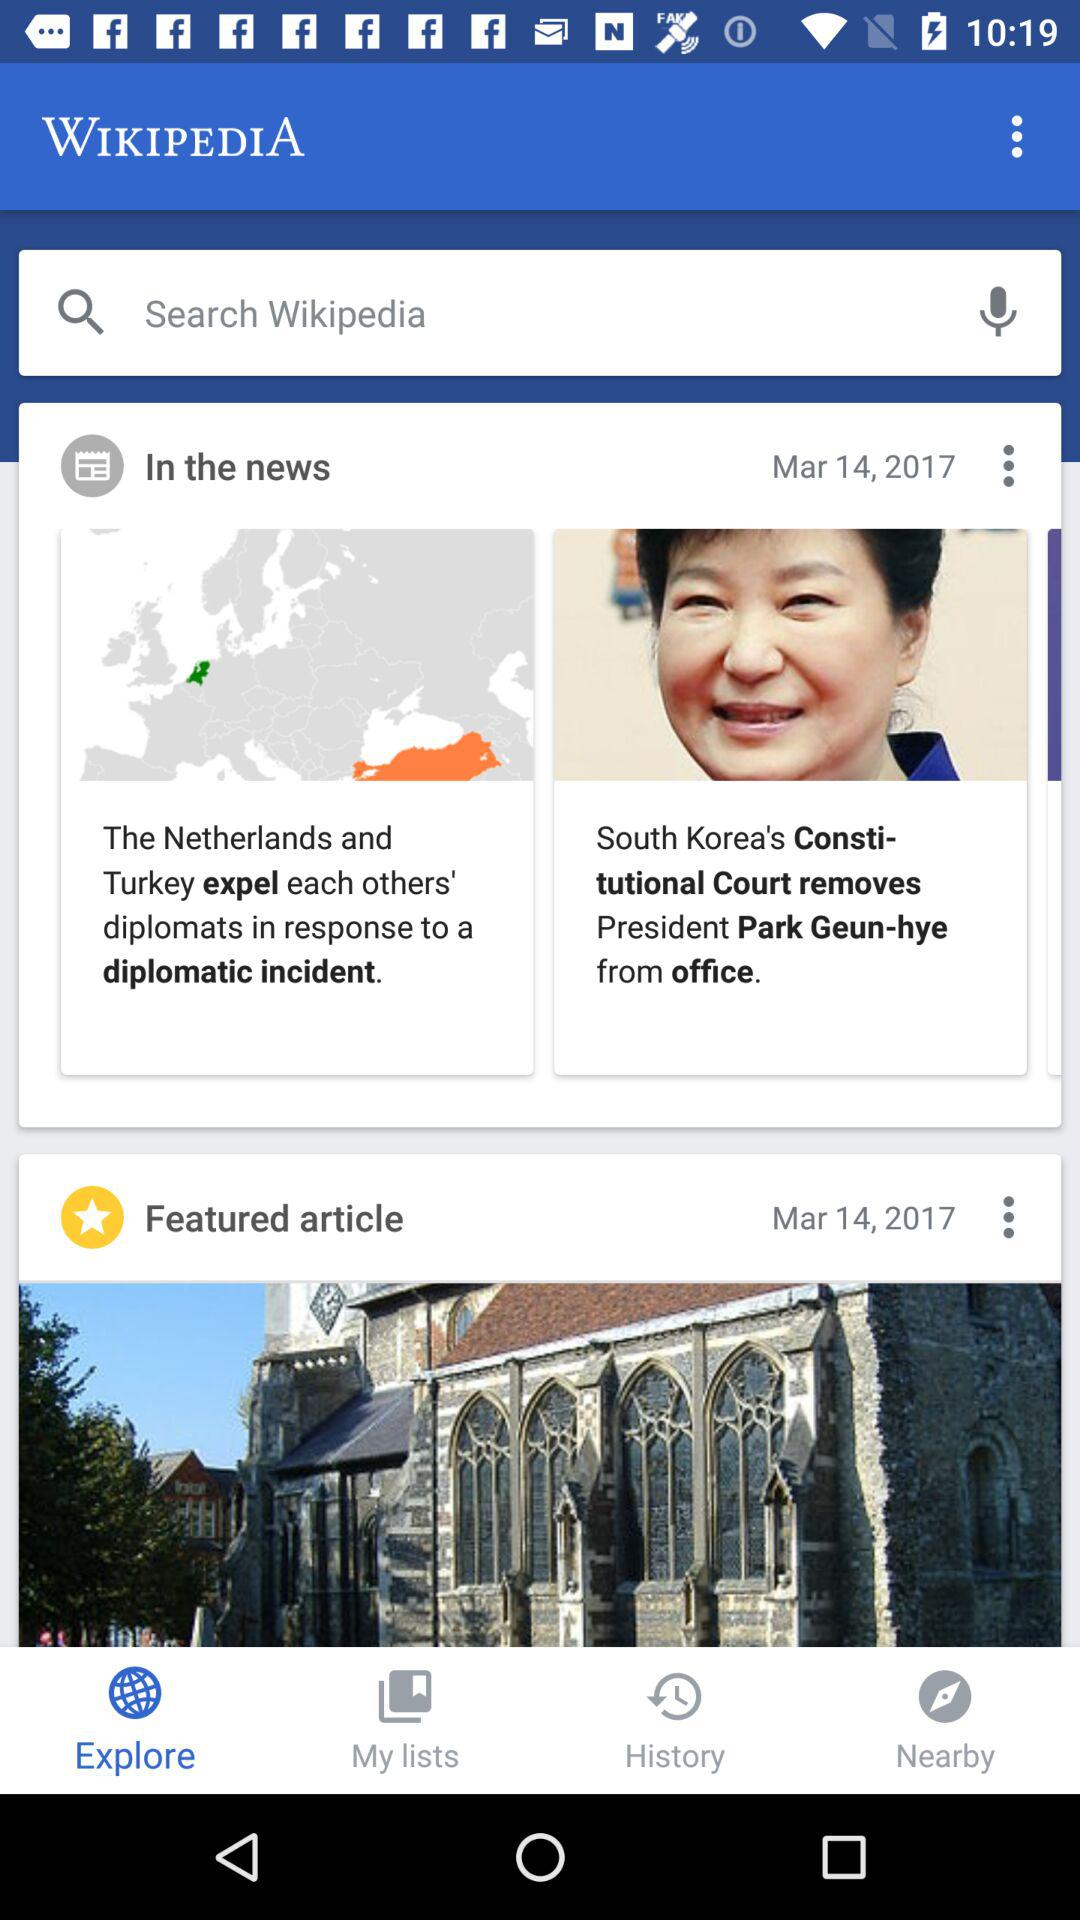What is the application name? The application name is "WIKIPEDIA". 